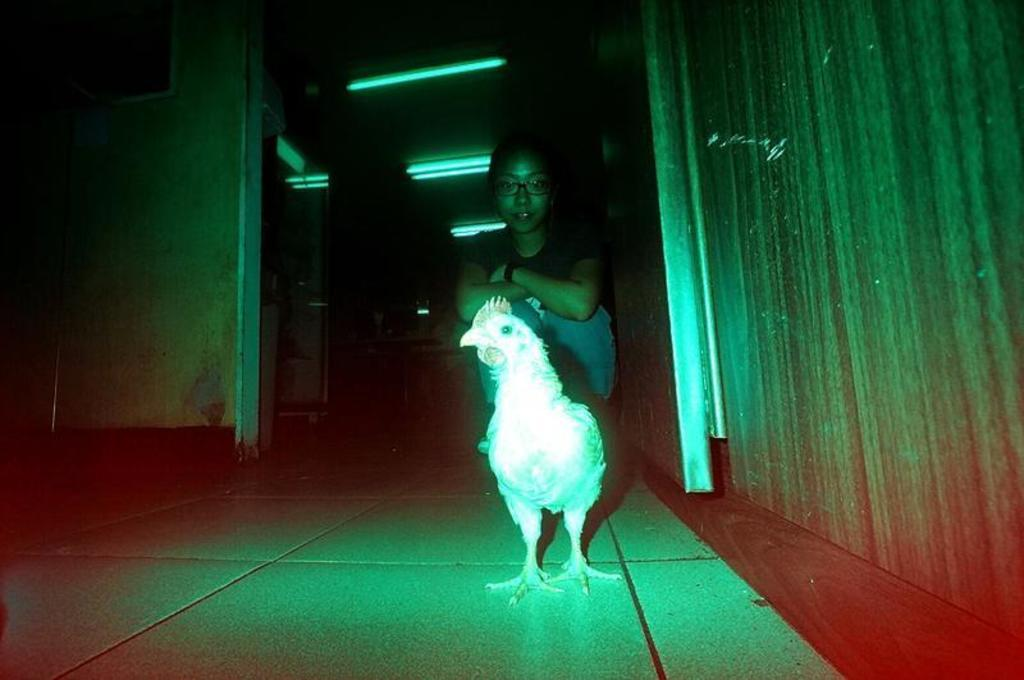Who is present in the image? There is a woman in the image. What is the woman wearing on her face? The woman is wearing spectacles. What type of animal can be seen on the floor in the image? There is a hen on the floor in the image. What can be seen in the background of the image? There are tube lights and a wall in the background of the image. What grade does the woman receive for her performance in the image? There is no indication of a performance or grading system in the image, so it cannot be determined. --- Facts: 1. There is a car in the image. 2. The car is red. 3. The car has four wheels. 4. There is a road in the image. 5. The road is paved. Absurd Topics: parrot, ocean, volcano Conversation: What is the main subject of the image? The main subject of the image is a car. What color is the car? The car is red. How many wheels does the car have? The car has four wheels. What type of surface can be seen in the image? There is a road in the image, and it is paved. Reasoning: Let's think step by step in order to produce the conversation. We start by identifying the main subject in the image, which is the car. Then, we describe specific details about the car, such as its color and the number of wheels. Next, we mention the presence of the road, which is another important detail in the image. Finally, we describe the road's surface, which is paved. Absurd Question/Answer: Can you see a parrot flying over the ocean in the image? There is no parrot or ocean present in the image; it features a red car on a paved road. 